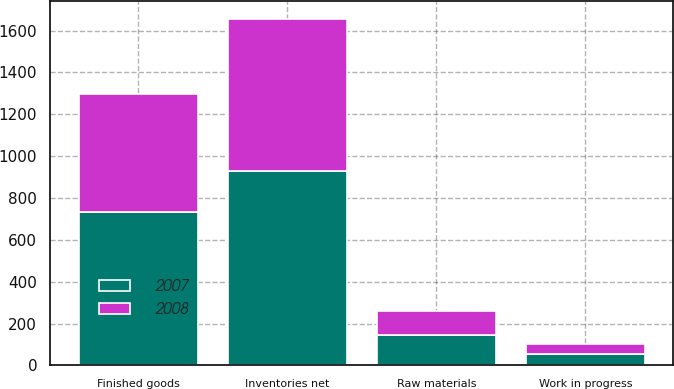Convert chart to OTSL. <chart><loc_0><loc_0><loc_500><loc_500><stacked_bar_chart><ecel><fcel>Finished goods<fcel>Work in progress<fcel>Raw materials<fcel>Inventories net<nl><fcel>2007<fcel>731.2<fcel>52.6<fcel>144.5<fcel>928.3<nl><fcel>2008<fcel>564.2<fcel>50.3<fcel>113.3<fcel>727.8<nl></chart> 